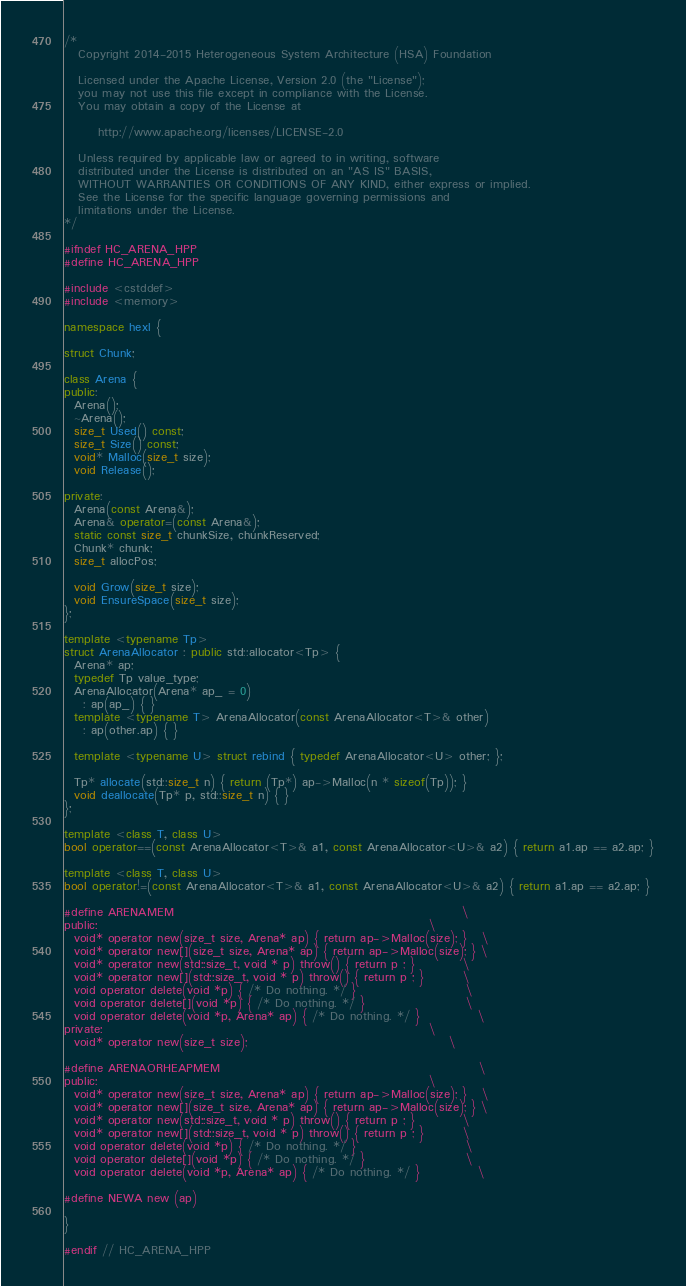Convert code to text. <code><loc_0><loc_0><loc_500><loc_500><_C++_>/*
   Copyright 2014-2015 Heterogeneous System Architecture (HSA) Foundation

   Licensed under the Apache License, Version 2.0 (the "License");
   you may not use this file except in compliance with the License.
   You may obtain a copy of the License at

       http://www.apache.org/licenses/LICENSE-2.0

   Unless required by applicable law or agreed to in writing, software
   distributed under the License is distributed on an "AS IS" BASIS,
   WITHOUT WARRANTIES OR CONDITIONS OF ANY KIND, either express or implied.
   See the License for the specific language governing permissions and
   limitations under the License.
*/

#ifndef HC_ARENA_HPP
#define HC_ARENA_HPP

#include <cstddef>
#include <memory>

namespace hexl {

struct Chunk;

class Arena {
public:
  Arena();
  ~Arena();
  size_t Used() const;
  size_t Size() const;
  void* Malloc(size_t size);
  void Release();

private:
  Arena(const Arena&);
  Arena& operator=(const Arena&);
  static const size_t chunkSize, chunkReserved;
  Chunk* chunk;
  size_t allocPos;

  void Grow(size_t size);
  void EnsureSpace(size_t size);
};

template <typename Tp>
struct ArenaAllocator : public std::allocator<Tp> {
  Arena* ap;
  typedef Tp value_type;
  ArenaAllocator(Arena* ap_ = 0)
    : ap(ap_) { }
  template <typename T> ArenaAllocator(const ArenaAllocator<T>& other)
    : ap(other.ap) { }

  template <typename U> struct rebind { typedef ArenaAllocator<U> other; };

  Tp* allocate(std::size_t n) { return (Tp*) ap->Malloc(n * sizeof(Tp)); }
  void deallocate(Tp* p, std::size_t n) { }
};

template <class T, class U>
bool operator==(const ArenaAllocator<T>& a1, const ArenaAllocator<U>& a2) { return a1.ap == a2.ap; }

template <class T, class U>
bool operator!=(const ArenaAllocator<T>& a1, const ArenaAllocator<U>& a2) { return a1.ap == a2.ap; }

#define ARENAMEM                                                            \
public:                                                                     \
  void* operator new(size_t size, Arena* ap) { return ap->Malloc(size); }   \
  void* operator new[](size_t size, Arena* ap) { return ap->Malloc(size); } \
  void* operator new(std::size_t, void * p) throw() { return p ; }          \
  void* operator new[](std::size_t, void * p) throw() { return p ; }        \
  void operator delete(void *p) { /* Do nothing. */ }                       \
  void operator delete[](void *p) { /* Do nothing. */ }                     \
  void operator delete(void *p, Arena* ap) { /* Do nothing. */ }            \
private:                                                                    \
  void* operator new(size_t size);                                          \

#define ARENAORHEAPMEM                                                      \
public:                                                                     \
  void* operator new(size_t size, Arena* ap) { return ap->Malloc(size); }   \
  void* operator new[](size_t size, Arena* ap) { return ap->Malloc(size); } \
  void* operator new(std::size_t, void * p) throw() { return p ; }          \
  void* operator new[](std::size_t, void * p) throw() { return p ; }        \
  void operator delete(void *p) { /* Do nothing. */ }                       \
  void operator delete[](void *p) { /* Do nothing. */ }                     \
  void operator delete(void *p, Arena* ap) { /* Do nothing. */ }            \

#define NEWA new (ap)

}

#endif // HC_ARENA_HPP
</code> 